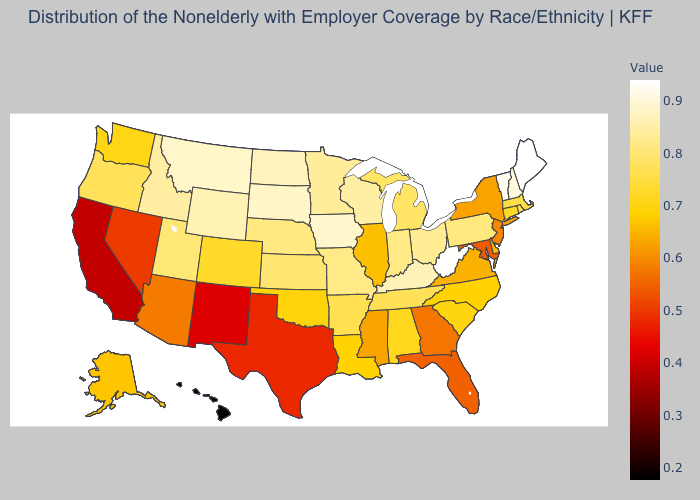Does Maine have the highest value in the USA?
Short answer required. Yes. Which states have the lowest value in the MidWest?
Keep it brief. Illinois. Among the states that border Rhode Island , does Connecticut have the highest value?
Give a very brief answer. No. Among the states that border Rhode Island , does Massachusetts have the lowest value?
Concise answer only. No. Does North Dakota have the lowest value in the MidWest?
Give a very brief answer. No. Does New York have a higher value than Alabama?
Keep it brief. No. 